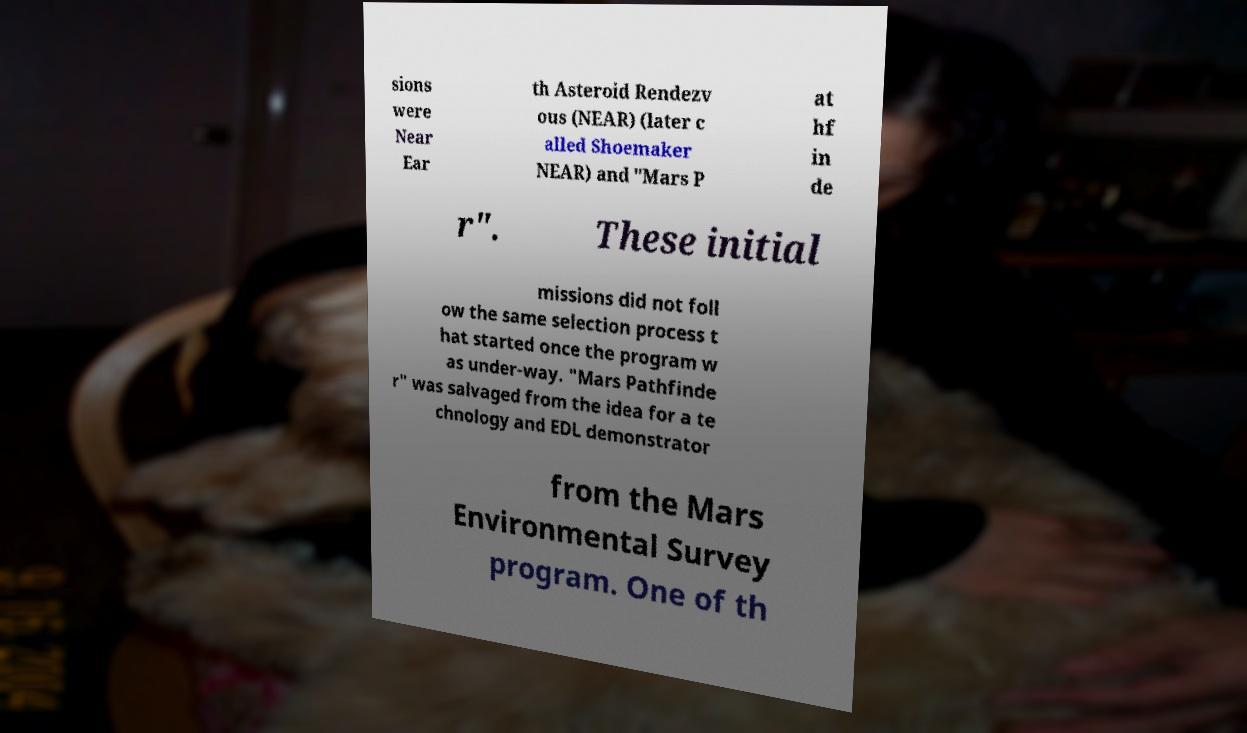Could you assist in decoding the text presented in this image and type it out clearly? sions were Near Ear th Asteroid Rendezv ous (NEAR) (later c alled Shoemaker NEAR) and "Mars P at hf in de r". These initial missions did not foll ow the same selection process t hat started once the program w as under-way. "Mars Pathfinde r" was salvaged from the idea for a te chnology and EDL demonstrator from the Mars Environmental Survey program. One of th 